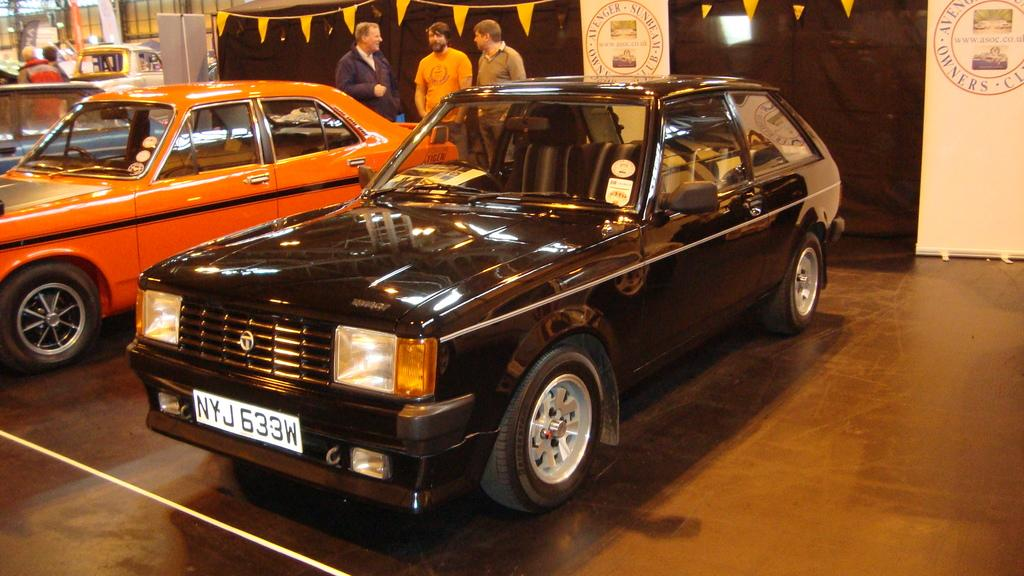What type of vehicles can be seen in the image? There are cars in the image. What are the people in the image doing? There are persons standing on the ground in the image. What can be seen in the background of the image? There are banners and flags in the background of the image. Can you describe the waves in the image? There are no waves present in the image. What type of tiger can be seen in the image? There is no tiger present in the image. 